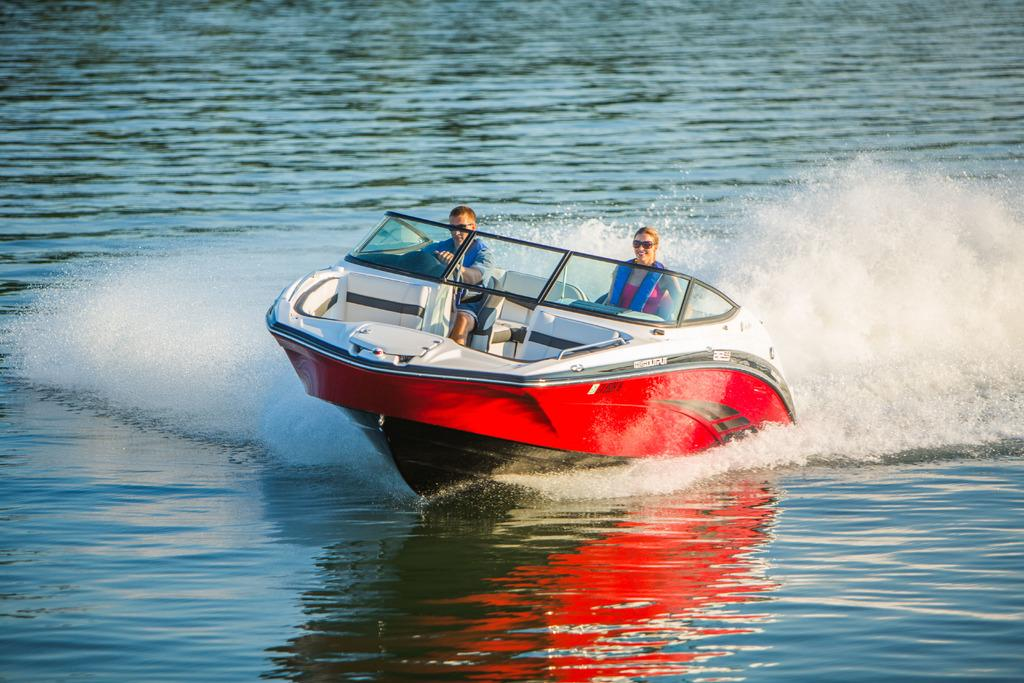How many people are in the image? There are two persons in the image. What are the two persons doing in the image? The two persons are sitting in a motor. Where is the motor located in the image? The motor is in the water. Can you describe the positions of the two persons in the motor? There is a man on the left side of the motor and a woman on the right side of the motor. What are the two persons sitting on in the motor? Both the man and the woman are sitting in chairs. How many matches are visible in the image? There are no matches present in the image. What type of geese can be seen swimming in the water near the motor? There are no geese present in the image; the motor is in the water, but no geese are visible. 